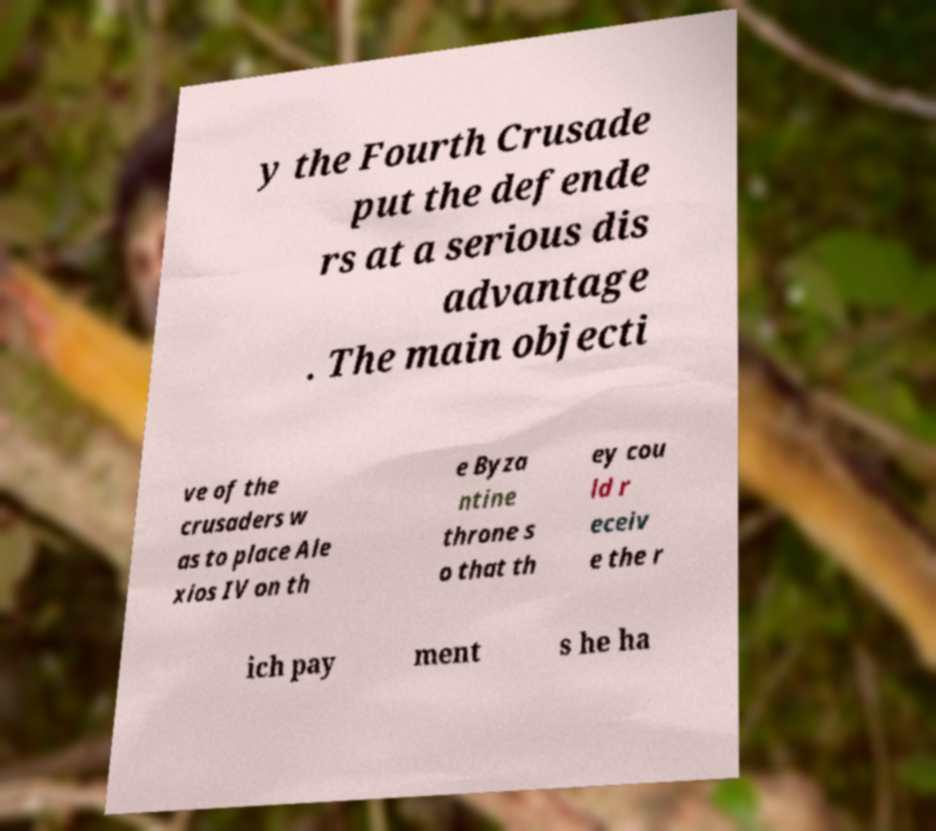Could you assist in decoding the text presented in this image and type it out clearly? y the Fourth Crusade put the defende rs at a serious dis advantage . The main objecti ve of the crusaders w as to place Ale xios IV on th e Byza ntine throne s o that th ey cou ld r eceiv e the r ich pay ment s he ha 